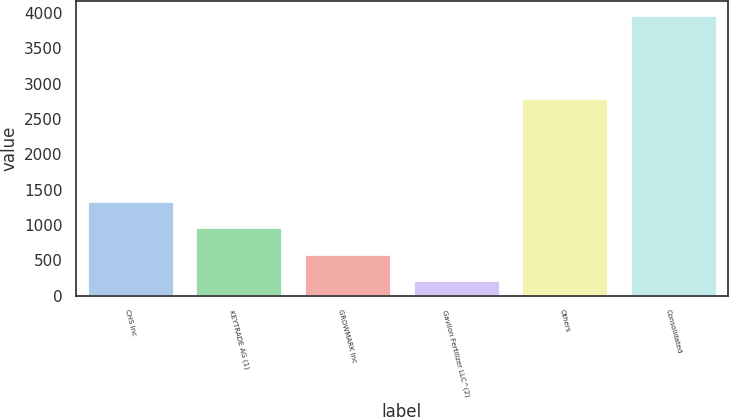Convert chart to OTSL. <chart><loc_0><loc_0><loc_500><loc_500><bar_chart><fcel>CHS Inc<fcel>KEYTRADE AG (1)<fcel>GROWMARK Inc<fcel>Gavilon Fertilizer LLC^(2)<fcel>Others<fcel>Consolidated<nl><fcel>1340.49<fcel>965.56<fcel>590.63<fcel>215.7<fcel>2800.2<fcel>3965<nl></chart> 